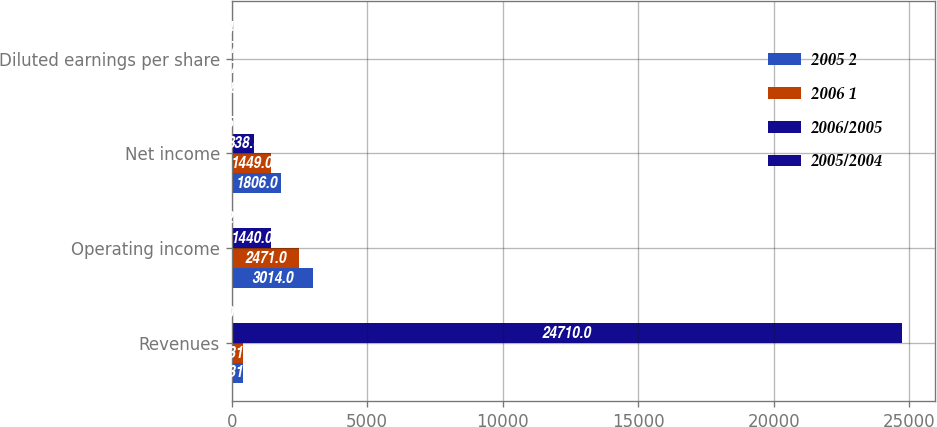Convert chart. <chart><loc_0><loc_0><loc_500><loc_500><stacked_bar_chart><ecel><fcel>Revenues<fcel>Operating income<fcel>Net income<fcel>Diluted earnings per share<nl><fcel>2005 2<fcel>431.5<fcel>3014<fcel>1806<fcel>5.83<nl><fcel>2006 1<fcel>431.5<fcel>2471<fcel>1449<fcel>4.72<nl><fcel>2006/2005<fcel>24710<fcel>1440<fcel>838<fcel>2.76<nl><fcel>2005/2004<fcel>10<fcel>22<fcel>25<fcel>24<nl></chart> 